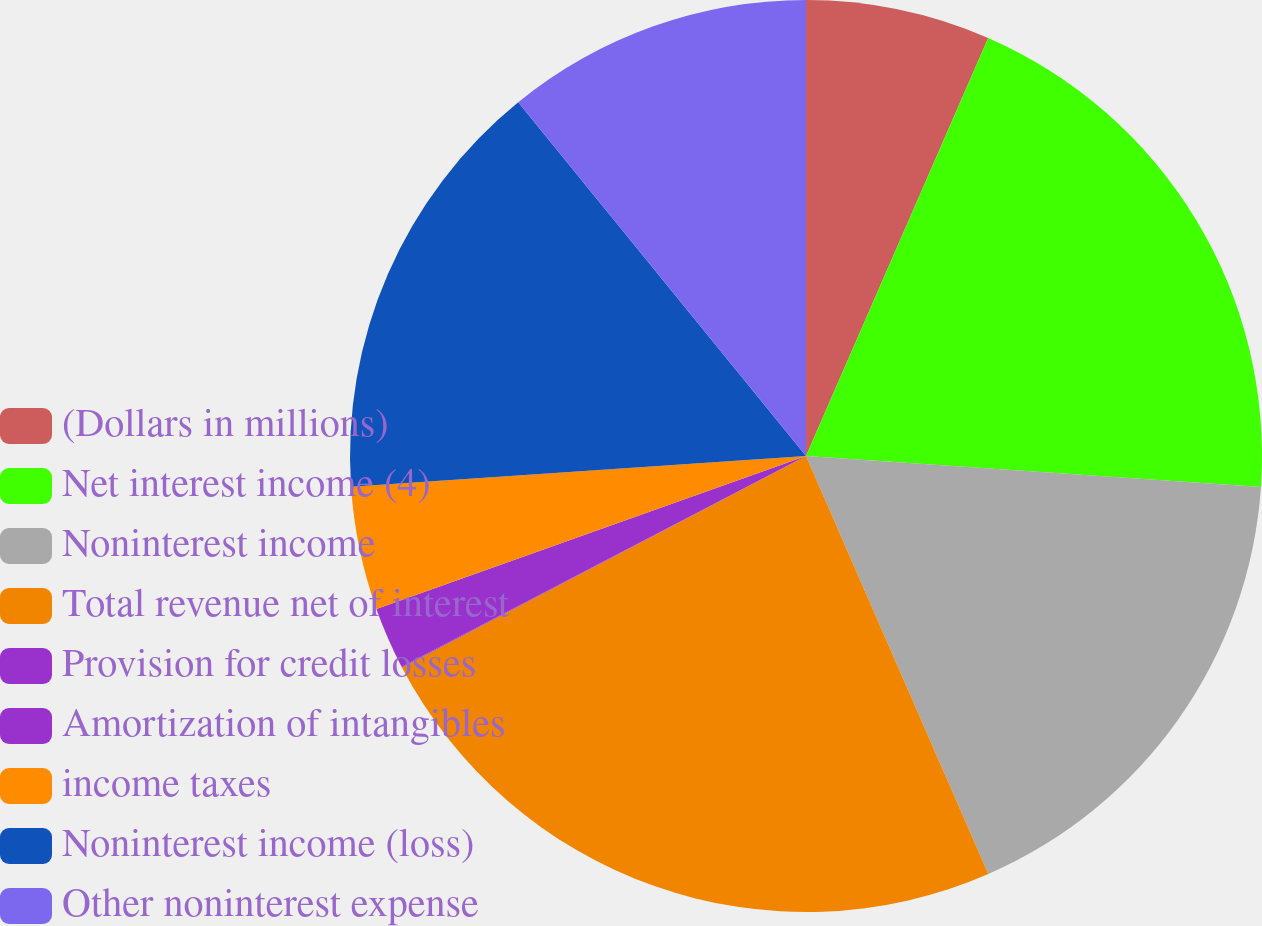Convert chart to OTSL. <chart><loc_0><loc_0><loc_500><loc_500><pie_chart><fcel>(Dollars in millions)<fcel>Net interest income (4)<fcel>Noninterest income<fcel>Total revenue net of interest<fcel>Provision for credit losses<fcel>Amortization of intangibles<fcel>income taxes<fcel>Noninterest income (loss)<fcel>Other noninterest expense<nl><fcel>6.54%<fcel>19.54%<fcel>17.37%<fcel>23.87%<fcel>0.03%<fcel>2.2%<fcel>4.37%<fcel>15.2%<fcel>10.87%<nl></chart> 